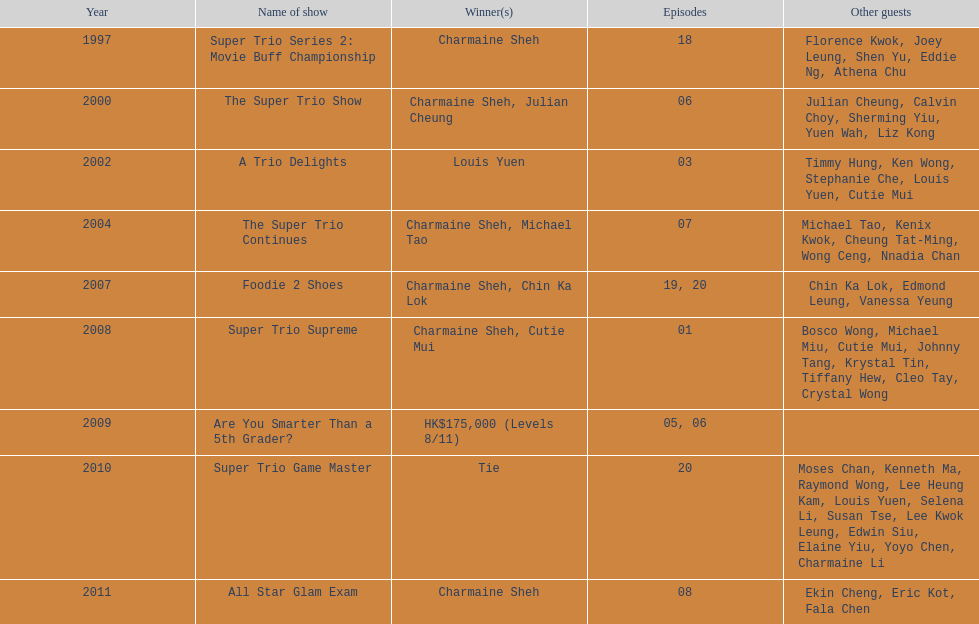Parse the table in full. {'header': ['Year', 'Name of show', 'Winner(s)', 'Episodes', 'Other guests'], 'rows': [['1997', 'Super Trio Series 2: Movie Buff Championship', 'Charmaine Sheh', '18', 'Florence Kwok, Joey Leung, Shen Yu, Eddie Ng, Athena Chu'], ['2000', 'The Super Trio Show', 'Charmaine Sheh, Julian Cheung', '06', 'Julian Cheung, Calvin Choy, Sherming Yiu, Yuen Wah, Liz Kong'], ['2002', 'A Trio Delights', 'Louis Yuen', '03', 'Timmy Hung, Ken Wong, Stephanie Che, Louis Yuen, Cutie Mui'], ['2004', 'The Super Trio Continues', 'Charmaine Sheh, Michael Tao', '07', 'Michael Tao, Kenix Kwok, Cheung Tat-Ming, Wong Ceng, Nnadia Chan'], ['2007', 'Foodie 2 Shoes', 'Charmaine Sheh, Chin Ka Lok', '19, 20', 'Chin Ka Lok, Edmond Leung, Vanessa Yeung'], ['2008', 'Super Trio Supreme', 'Charmaine Sheh, Cutie Mui', '01', 'Bosco Wong, Michael Miu, Cutie Mui, Johnny Tang, Krystal Tin, Tiffany Hew, Cleo Tay, Crystal Wong'], ['2009', 'Are You Smarter Than a 5th Grader?', 'HK$175,000 (Levels 8/11)', '05, 06', ''], ['2010', 'Super Trio Game Master', 'Tie', '20', 'Moses Chan, Kenneth Ma, Raymond Wong, Lee Heung Kam, Louis Yuen, Selena Li, Susan Tse, Lee Kwok Leung, Edwin Siu, Elaine Yiu, Yoyo Chen, Charmaine Li'], ['2011', 'All Star Glam Exam', 'Charmaine Sheh', '08', 'Ekin Cheng, Eric Kot, Fala Chen']]} What year was the only year were a tie occurred? 2010. 